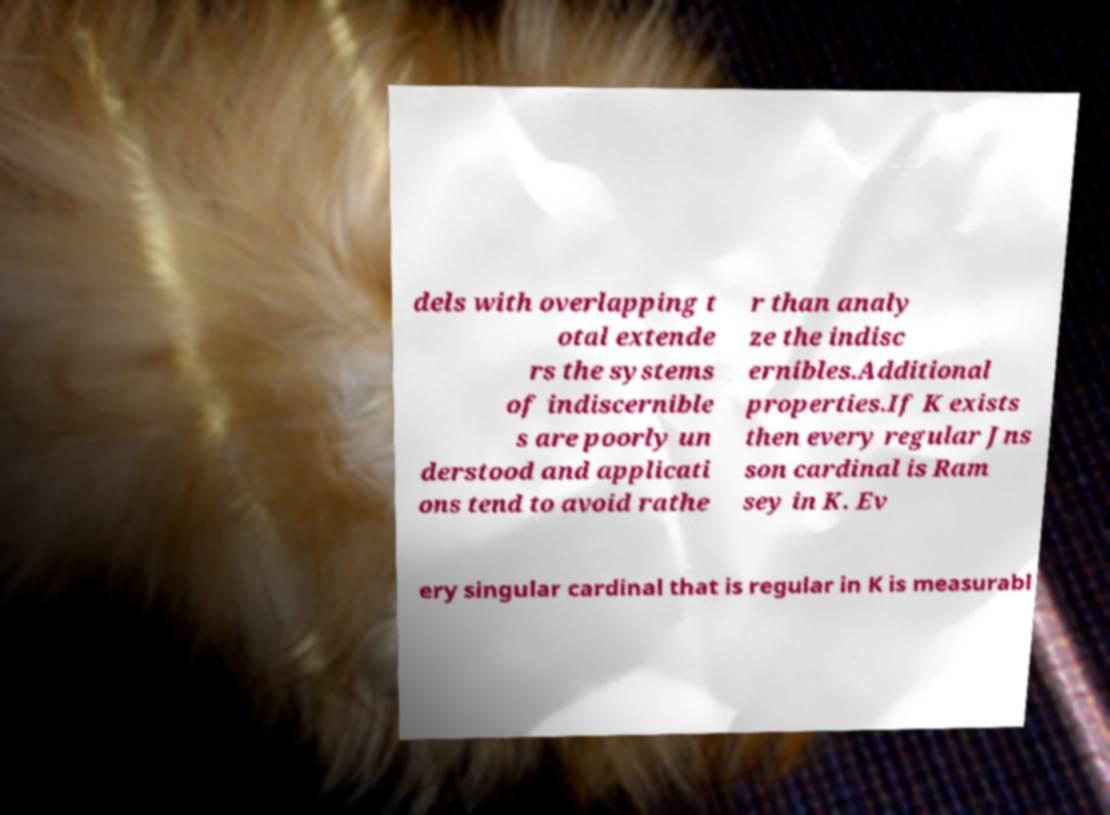There's text embedded in this image that I need extracted. Can you transcribe it verbatim? dels with overlapping t otal extende rs the systems of indiscernible s are poorly un derstood and applicati ons tend to avoid rathe r than analy ze the indisc ernibles.Additional properties.If K exists then every regular Jns son cardinal is Ram sey in K. Ev ery singular cardinal that is regular in K is measurabl 